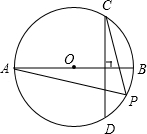What is the significance of the perpendicularity of chord CD on the diameter AB? The perpendicularity of chord CD on diameter AB is significant as it ensures that angle OCD and ODC are right angles. This setup allows us to apply the properties of semicircles and perpendicular diameters, directly influencing the symmetry and geometric relationships within the circle, such as equal arcs and angles generated by these right angles. 